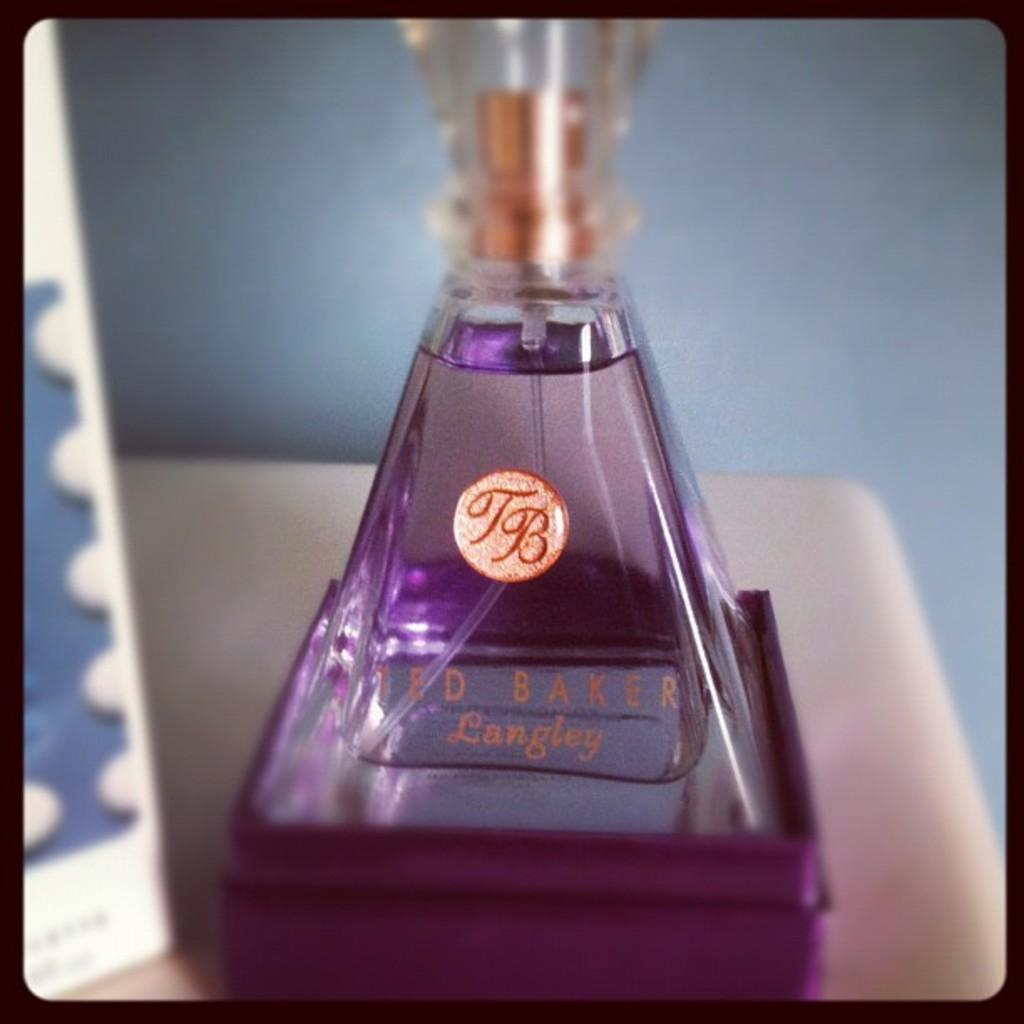<image>
Share a concise interpretation of the image provided. Purple bottle of Ted Baker perfume on top of a table. 